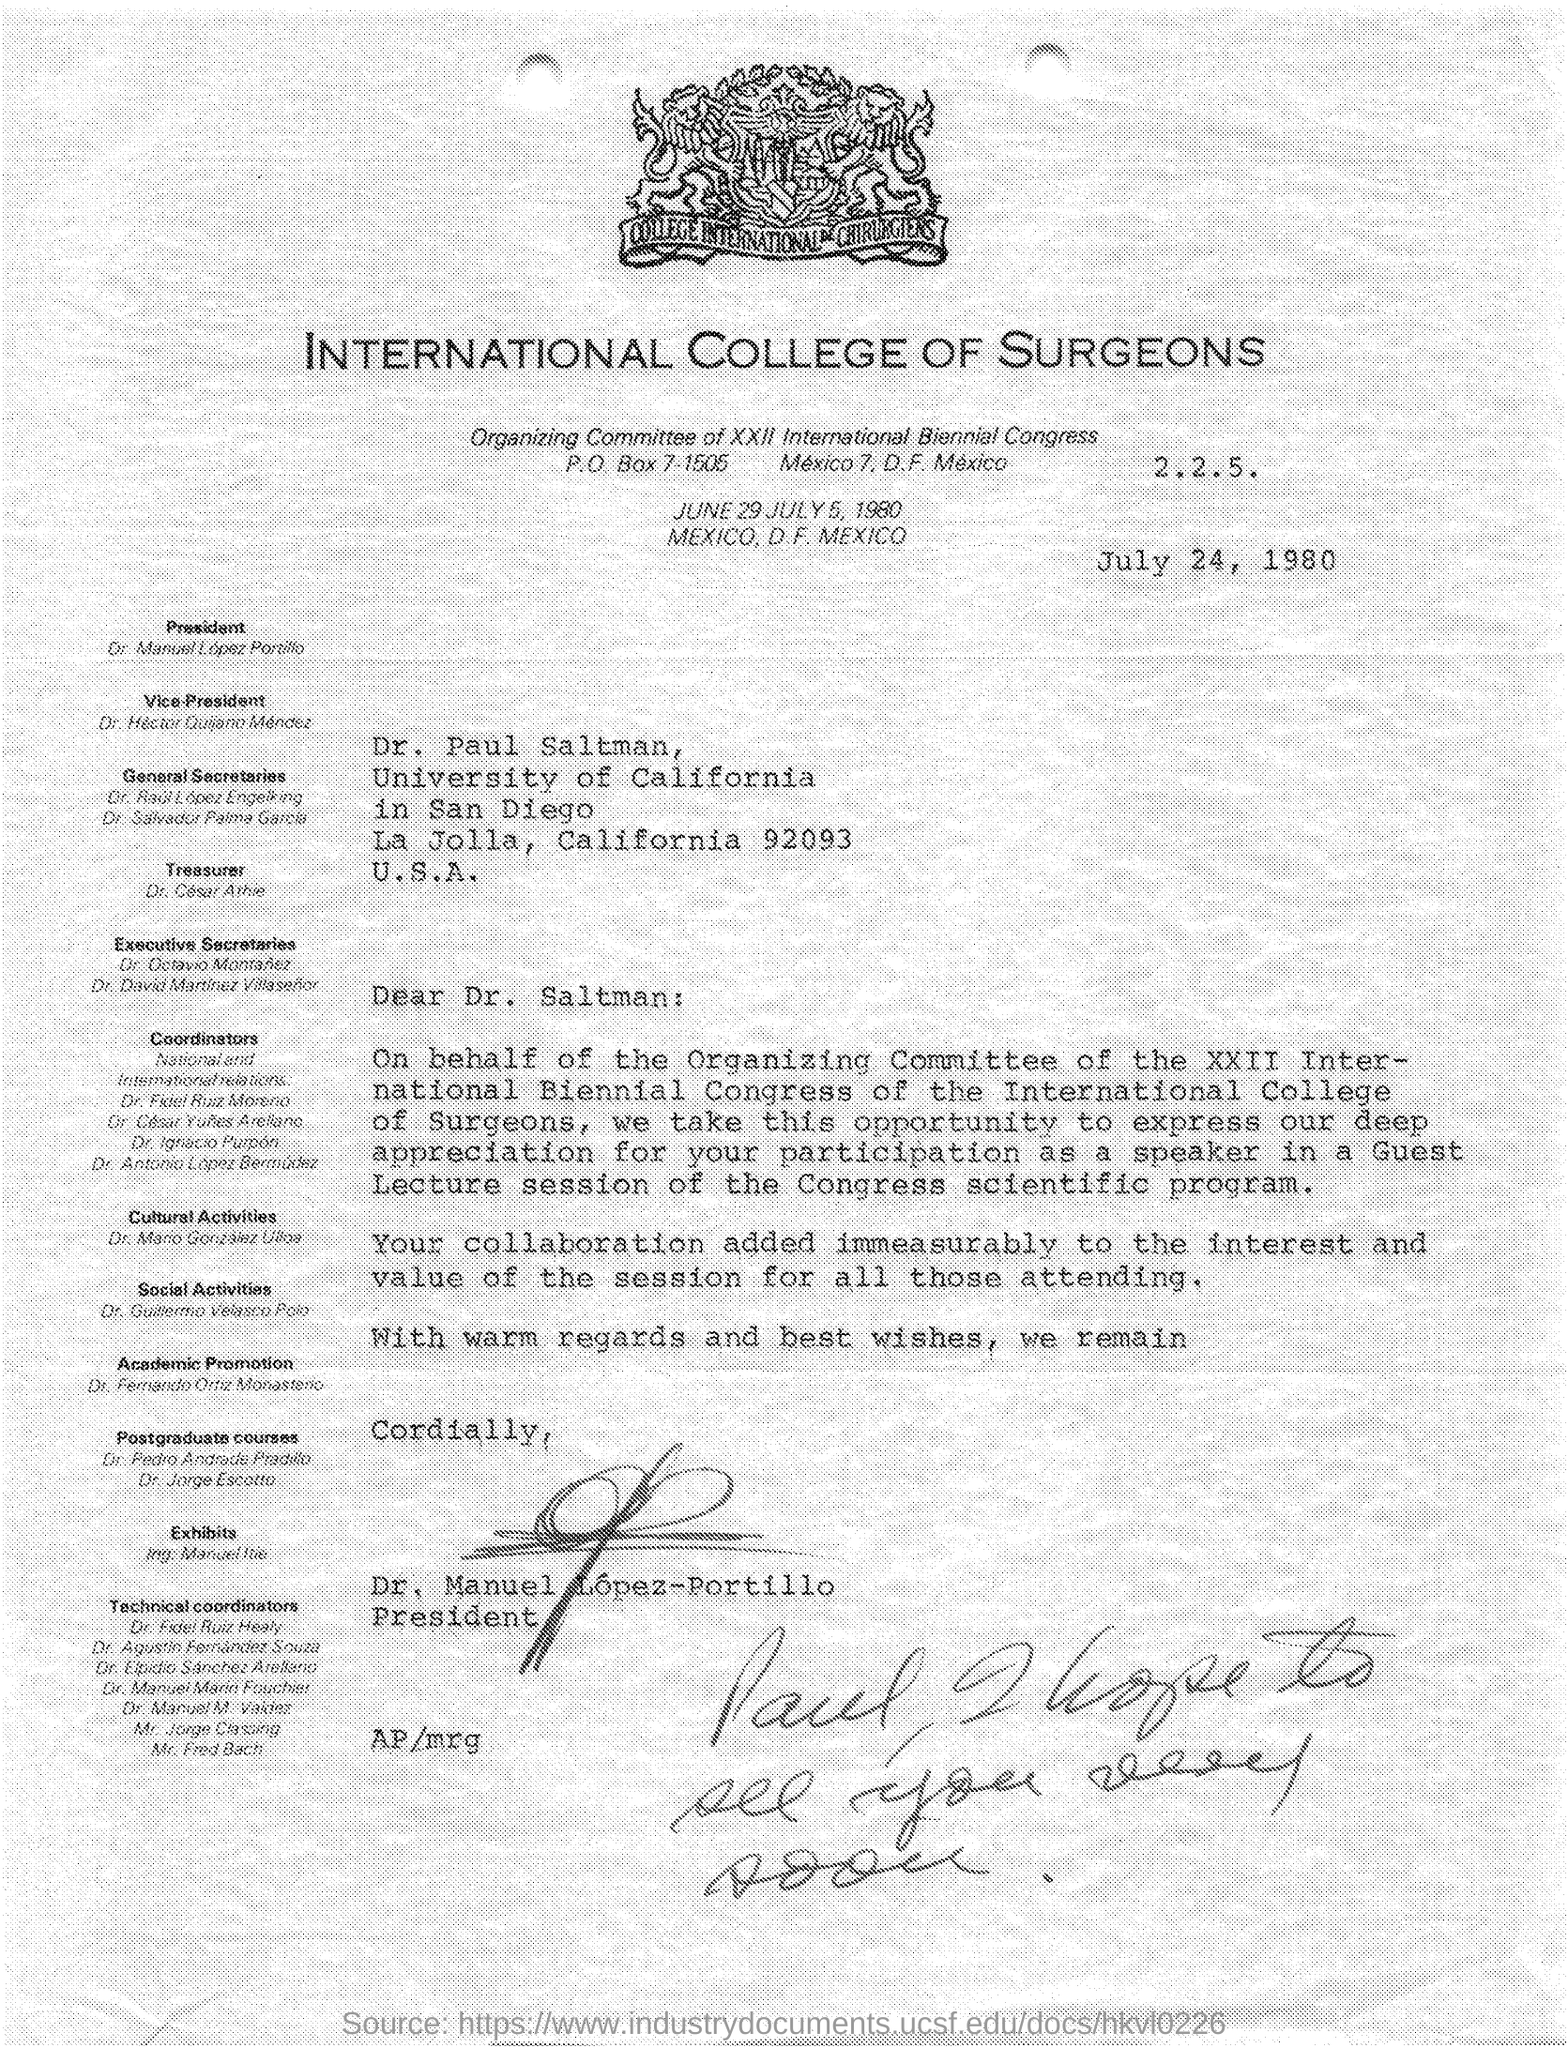When is this letter dated?
Ensure brevity in your answer.  July 24, 1980. 